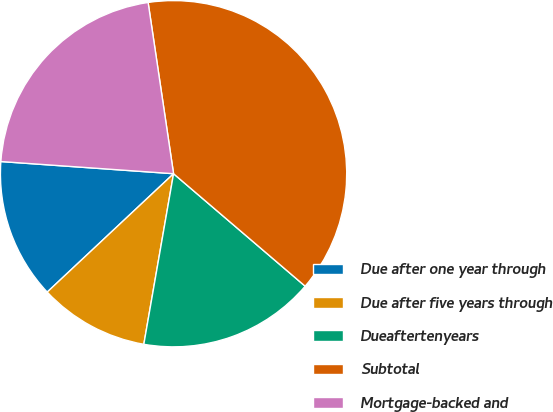<chart> <loc_0><loc_0><loc_500><loc_500><pie_chart><fcel>Due after one year through<fcel>Due after five years through<fcel>Dueaftertenyears<fcel>Subtotal<fcel>Mortgage-backed and<nl><fcel>13.1%<fcel>10.27%<fcel>16.49%<fcel>38.6%<fcel>21.53%<nl></chart> 